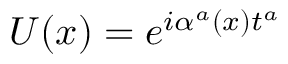<formula> <loc_0><loc_0><loc_500><loc_500>U ( x ) = e ^ { i \alpha ^ { a } ( x ) t ^ { a } }</formula> 